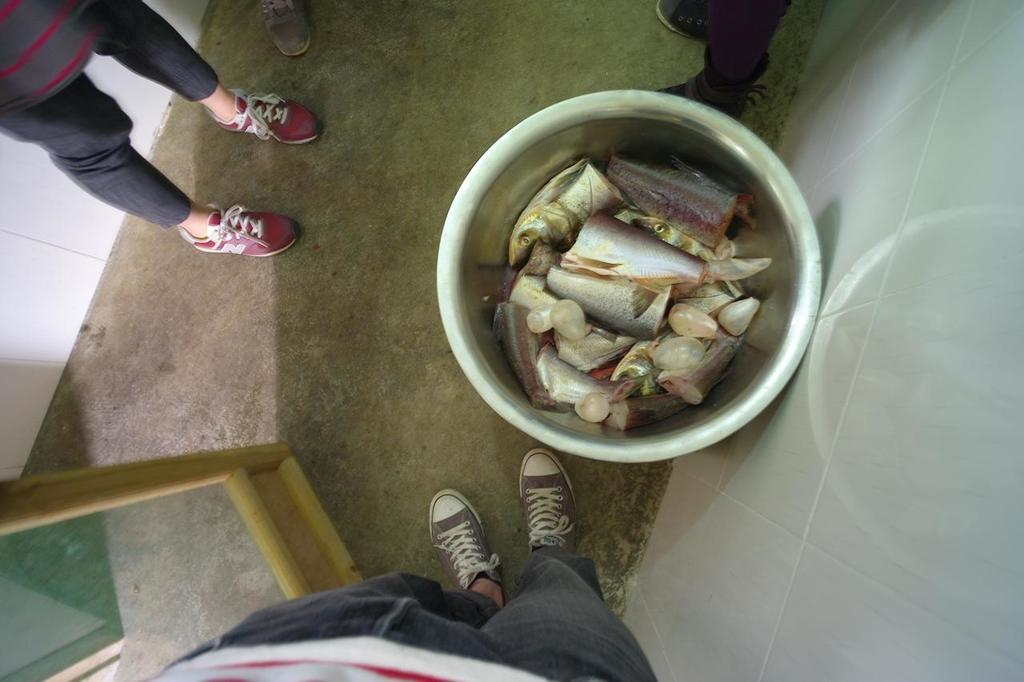How many people are in the image? There are two persons in the image. What is the main object in the image besides the people? There is a bowl in the image. What is inside the bowl? The bowl contains fishes. What type of stocking is visible on the person's leg in the image? There is no stocking visible on any person's leg in the image. 